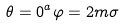Convert formula to latex. <formula><loc_0><loc_0><loc_500><loc_500>\theta = 0 ^ { a } \varphi = 2 m \sigma</formula> 